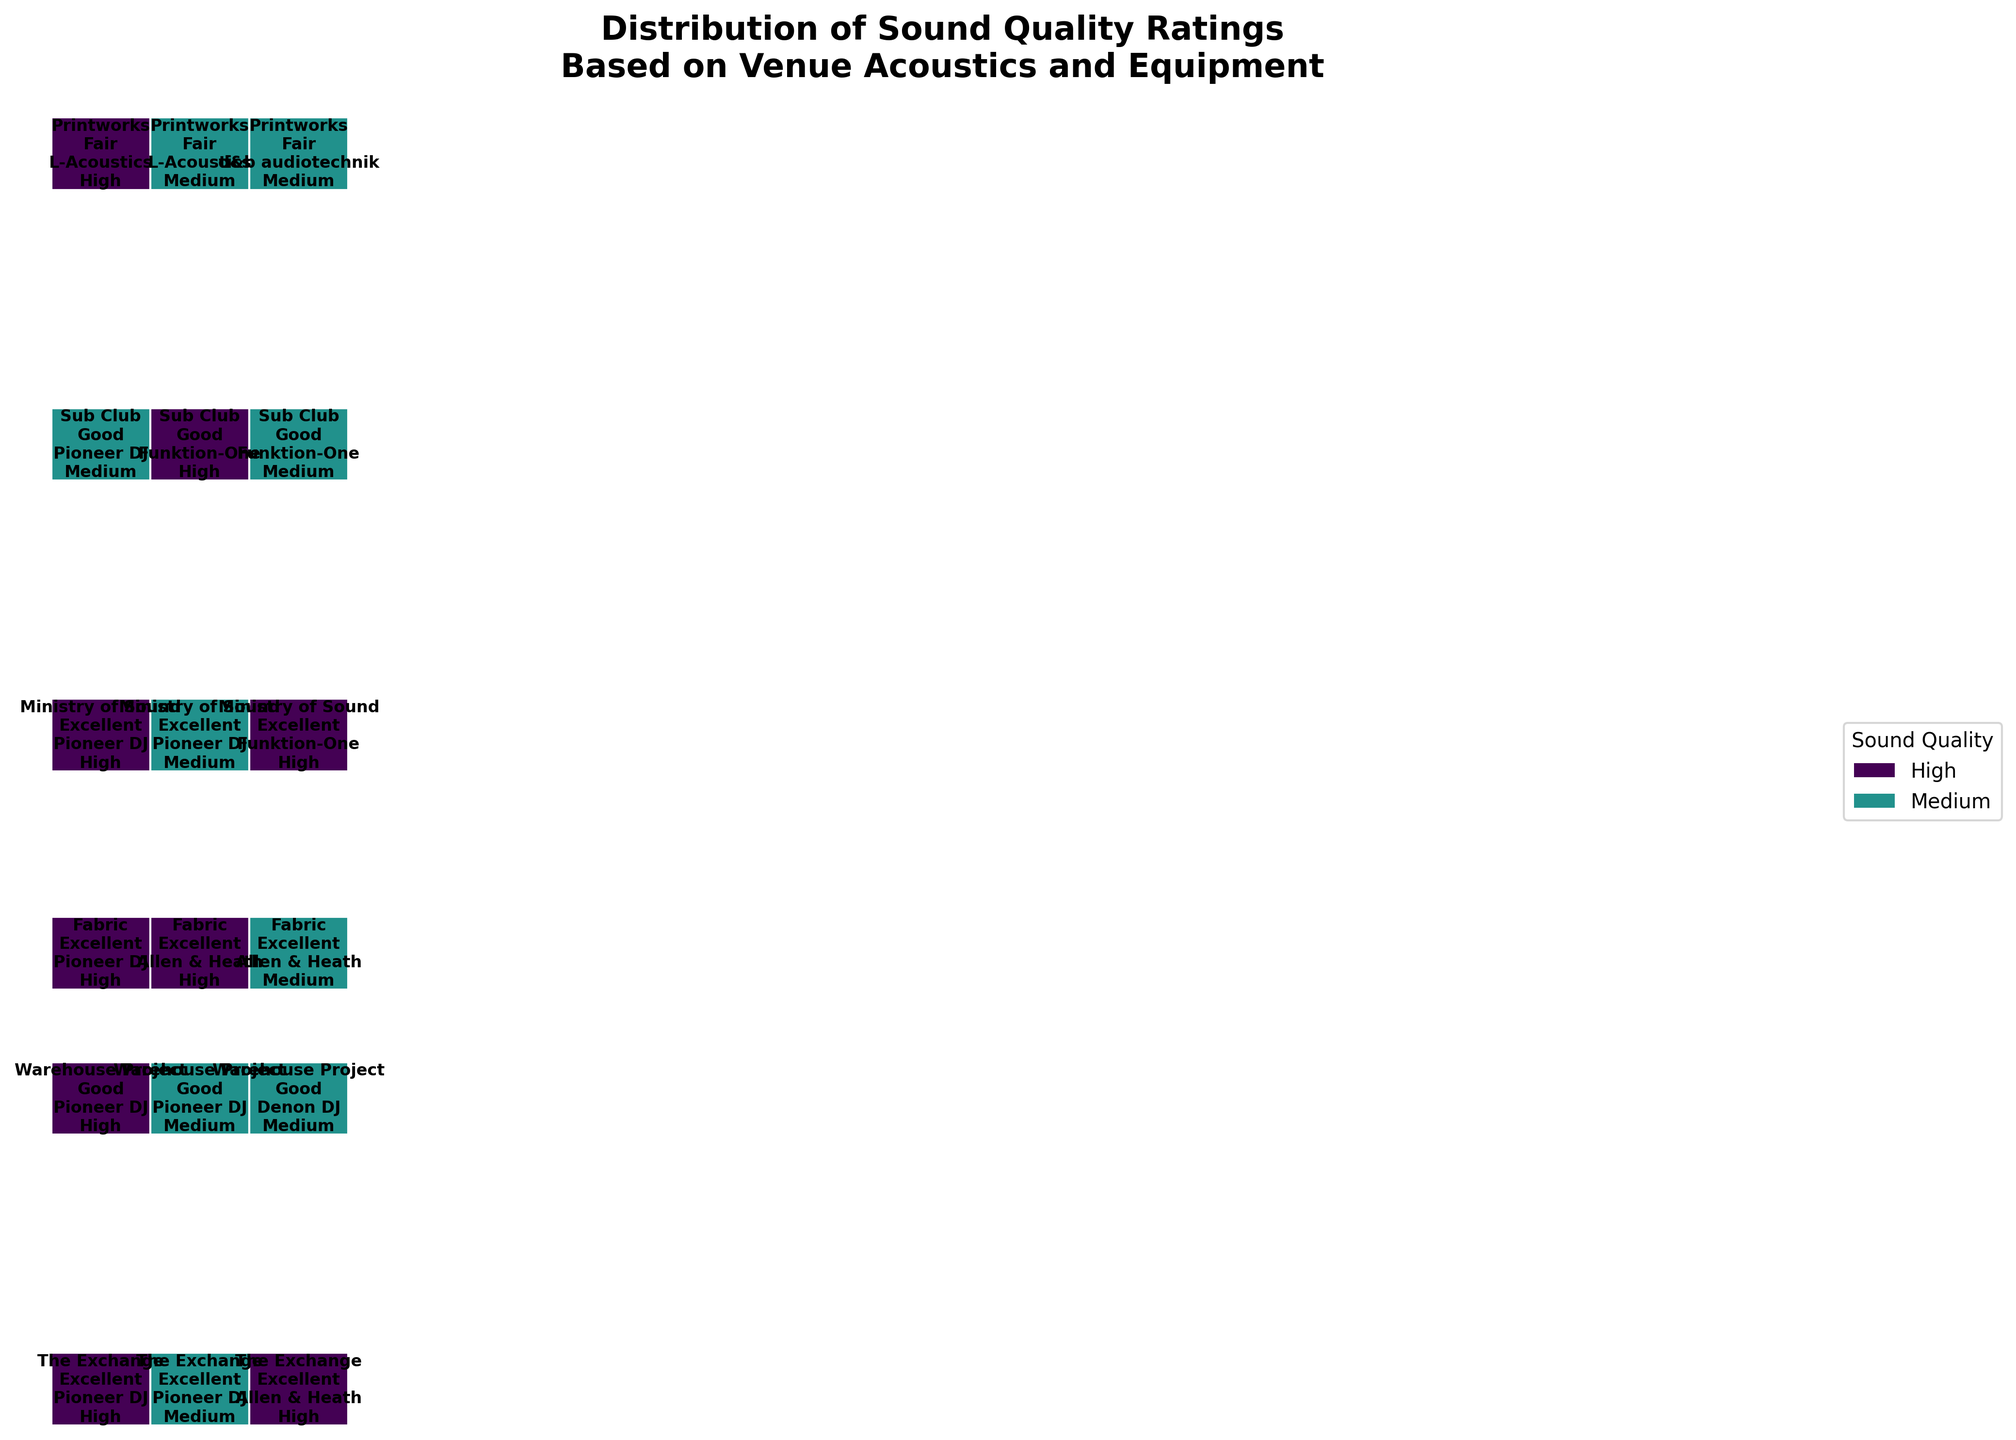What is the title of the plot? The title of the plot is located at the top and summarizes the main focus of the visualization. It reads 'Distribution of Sound Quality Ratings Based on Venue Acoustics and Equipment'.
Answer: Distribution of Sound Quality Ratings Based on Venue Acoustics and Equipment Which venue has Excellent acoustics with Pioneer DJ equipment? Look at the x-axis for Excellent acoustics and then search for the labels of Pioneer DJ within this category. The venues associated with this combination are The Exchange, Ministry of Sound, and Fabric.
Answer: The Exchange, Ministry of Sound, Fabric What percentage of the plots are labeled with 'High' sound quality? To determine the percentage, we need to examine the color coding correlating to 'High' sound quality (likely a distinct color) and then estimate the relative area those sections cover within the total. Assuming all individual width elements are mapped correctly, visually assess the proportion occupied by 'High' sound quality.
Answer: Approximately 50% Compare the sound quality ratings of L-Acoustics in the Printworks to that of Funktion-One in Sub Club. Which is better? Look at the sections labeled 'Printworks' and 'Sub Club' respectively. For each equipment in both locations, count the frequency of 'High' and 'Medium' sound quality ratings. Printworks with L-Acoustics predominantly show 'High', whereas Sub Club with Funktion-One also largely displays 'High'. A detailed comparison indicates that both perform similarly well, though any minor variations in area coverage favor L-Acoustics slightly.
Answer: Slightly better with L-Acoustics in Printworks What is the most common equipment associated with Excellent acoustics resulting in 'High' sound quality? Scan through the sections marked as 'Excellent' acoustics and specifically focus on blocks colored for 'High' sound quality. Identify which equipment label appears most frequently in these sections. Pioneer DJ seems to be the most prominent.
Answer: Pioneer DJ How does the distribution of 'Medium' sound quality ratings compare between Excellent and Good acoustics? Compare the sections of the plot allocated to ratings segmented into Excellent and Good acoustics. Quantify the visible area or count the frequencies for Medium in each of these categories, noting the prominence of width. Good acoustics appear to have more extensive 'Medium' ratings visually.
Answer: 'Medium' ratings are more common with Good acoustics Are there any venues where all equipment types result in 'High' sound quality? Check each venue for their respective equipment and sound quality combinations. Verify if all equipment listed under any venue results consistently in 'High' ratings. Ministry of Sound stands out in this case.
Answer: Ministry of Sound Which venue has the widest variation in sound quality ratings for Excellent acoustics? Look into the Excellent acoustics sections of each venue and observe the distribution across 'High' and 'Medium'. The venue with the most substantial presence of both categories indicates the widest variation. Fabric appears to have a balanced display of both ratings.
Answer: Fabric What's the distribution of sound quality ratings for Denon DJ equipment in any venue? Locate blocks of the plot designated for Denon DJ equipment, then note the segments labeled 'High' or 'Medium'. Warehouse Project showcases Denon DJ equipment predominantly with 'Medium' sound quality.
Answer: Predominantly 'Medium' 